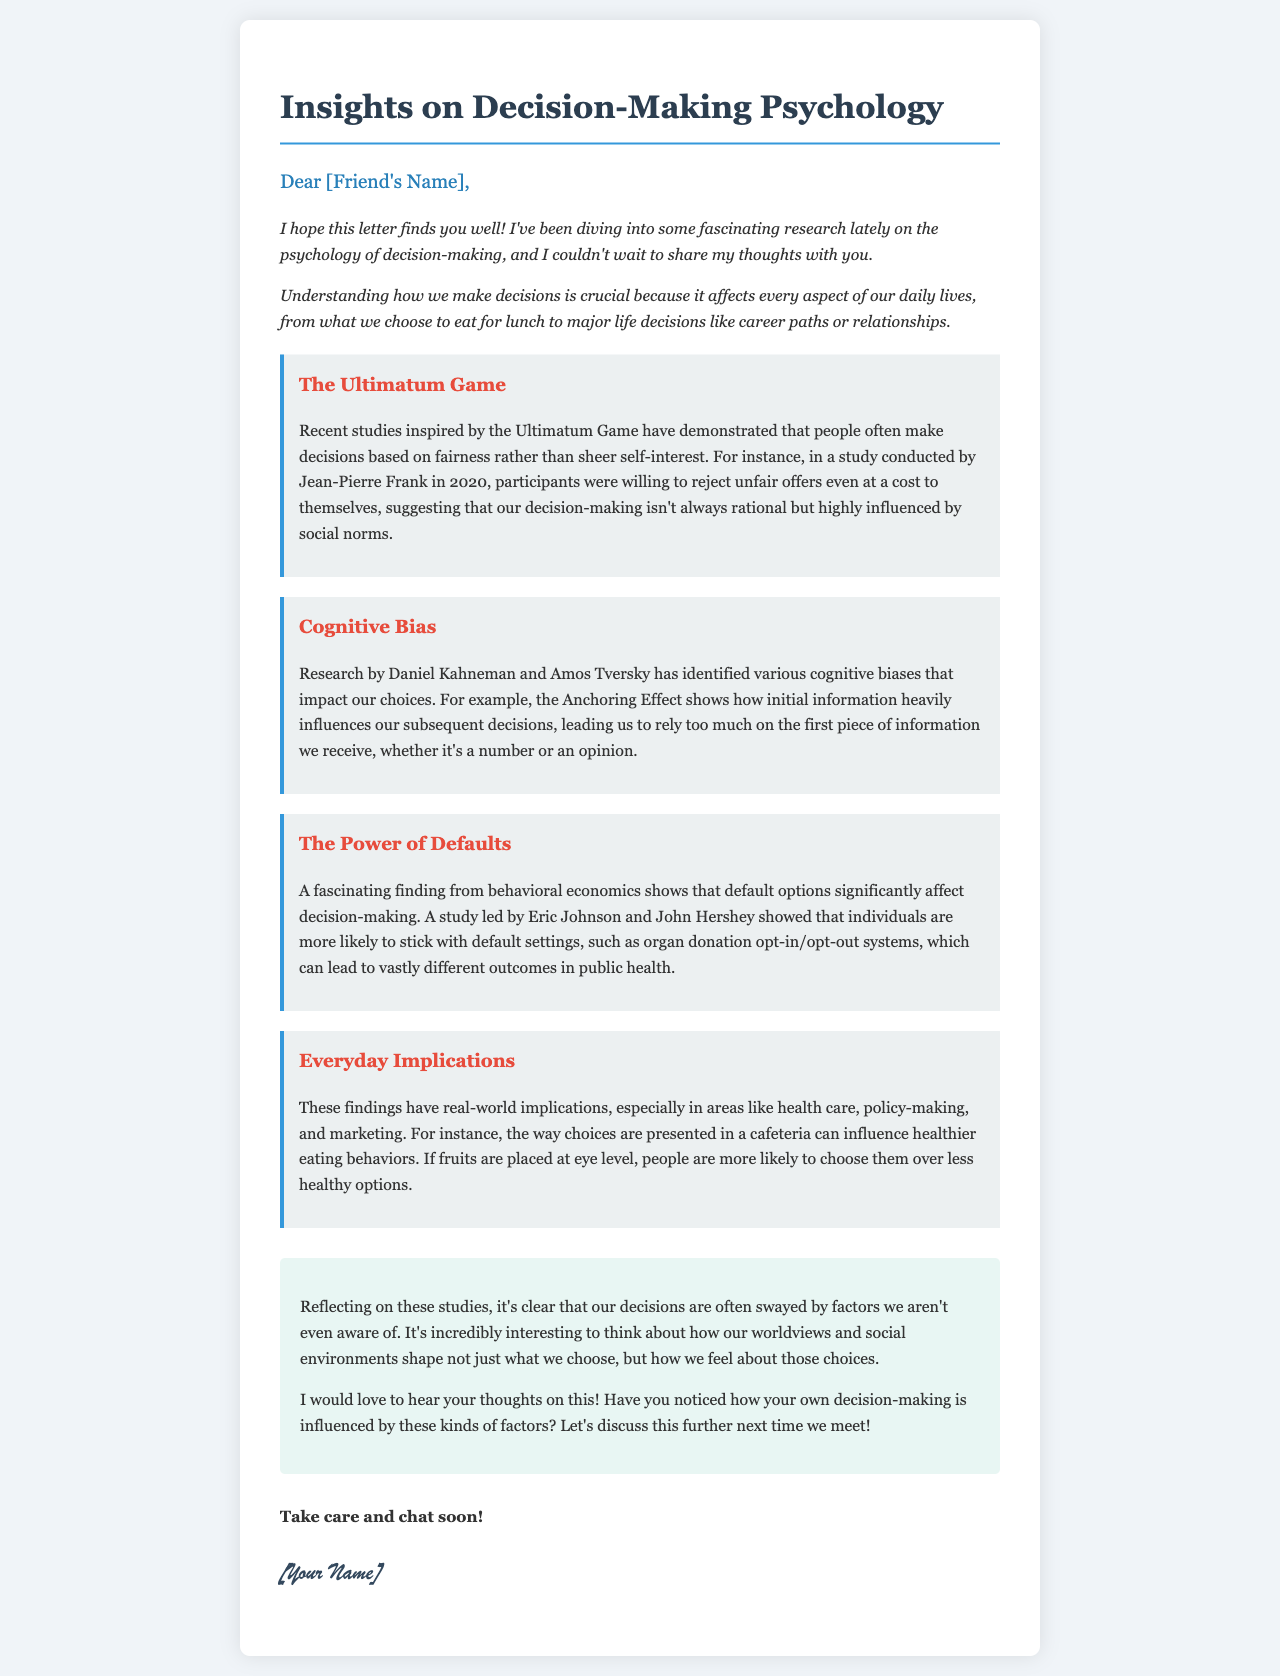What is the title of the letter? The title is presented prominently at the top of the document, indicating the main topic discussed in the letter.
Answer: Insights on Decision-Making Psychology Who conducted the Ultimatum Game study mentioned? The document specifies a particular researcher responsible for the study on fairness affecting decision-making.
Answer: Jean-Pierre Frank What cognitive bias is related to first impressions? The letter discusses a specific cognitive bias that describes reliance on initial information during decision-making processes.
Answer: Anchoring Effect Which two researchers are credited with identifying cognitive biases? The document identifies two key figures in the field of psychology known for their work regarding biases affecting choices.
Answer: Daniel Kahneman and Amos Tversky What is a real-world implication mentioned regarding default options? The letter references a specific context where default settings can significantly influence decision outcomes in public health.
Answer: Organ donation opt-in/opt-out systems What behavior was influenced by food placement in cafeterias? The findings in the letter describe how the arrangement of food items affects people's choices toward healthier options.
Answer: Healthier eating behaviors What was the main focus of the personal reflection section? In this part of the letter, the author reflects on broader implications of the studies discussed and their impact on individual choice.
Answer: Factors influencing decision-making What greeting is used at the beginning of the letter? The opening of the letter includes a friendly address to the recipient, setting a casual tone for the communication.
Answer: Dear [Friend's Name] 